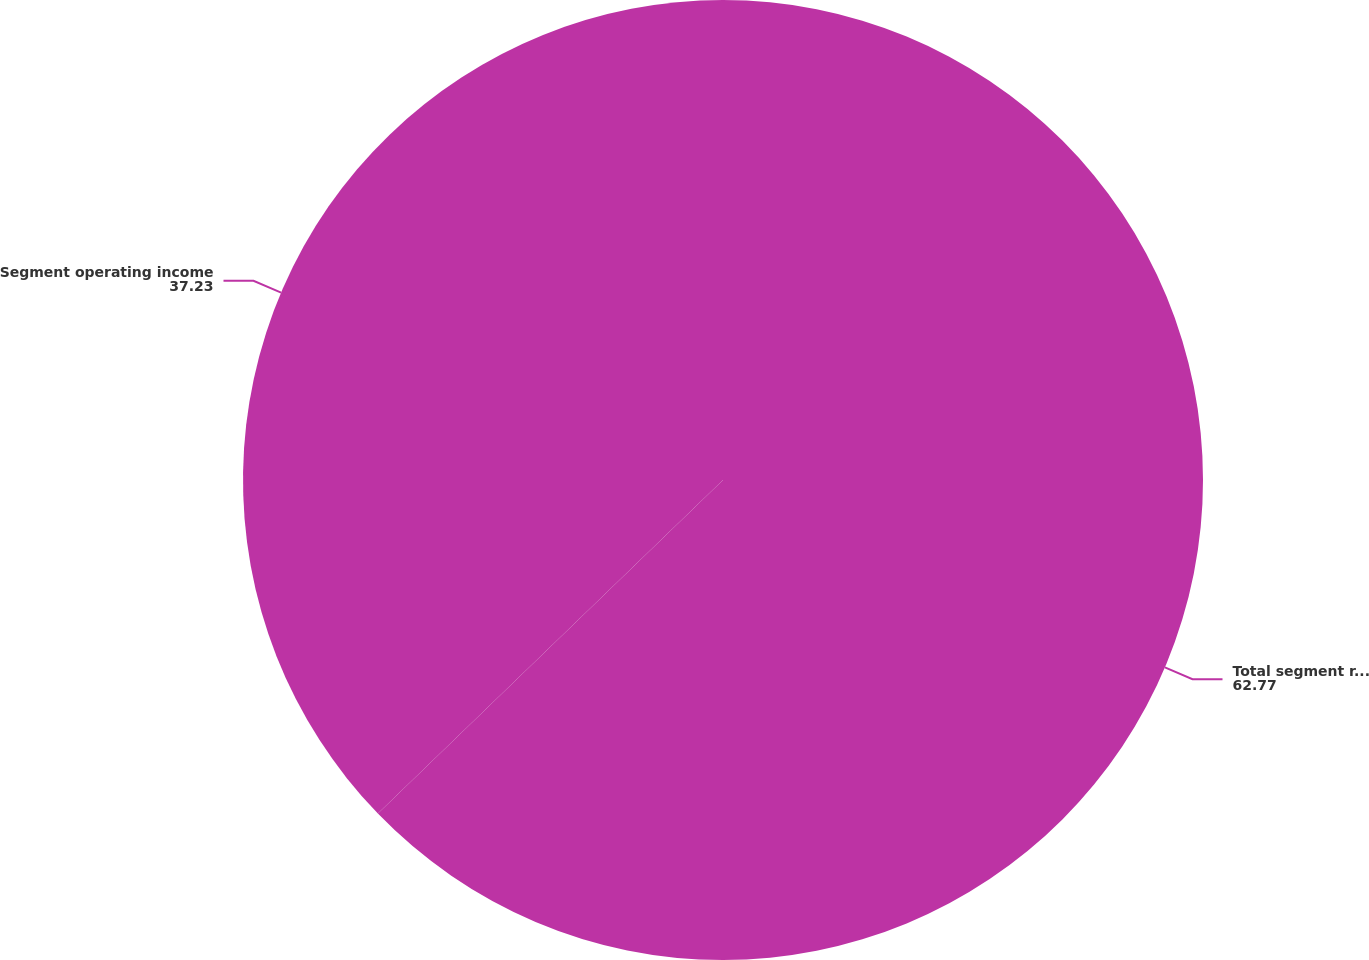<chart> <loc_0><loc_0><loc_500><loc_500><pie_chart><fcel>Total segment revenue<fcel>Segment operating income<nl><fcel>62.77%<fcel>37.23%<nl></chart> 